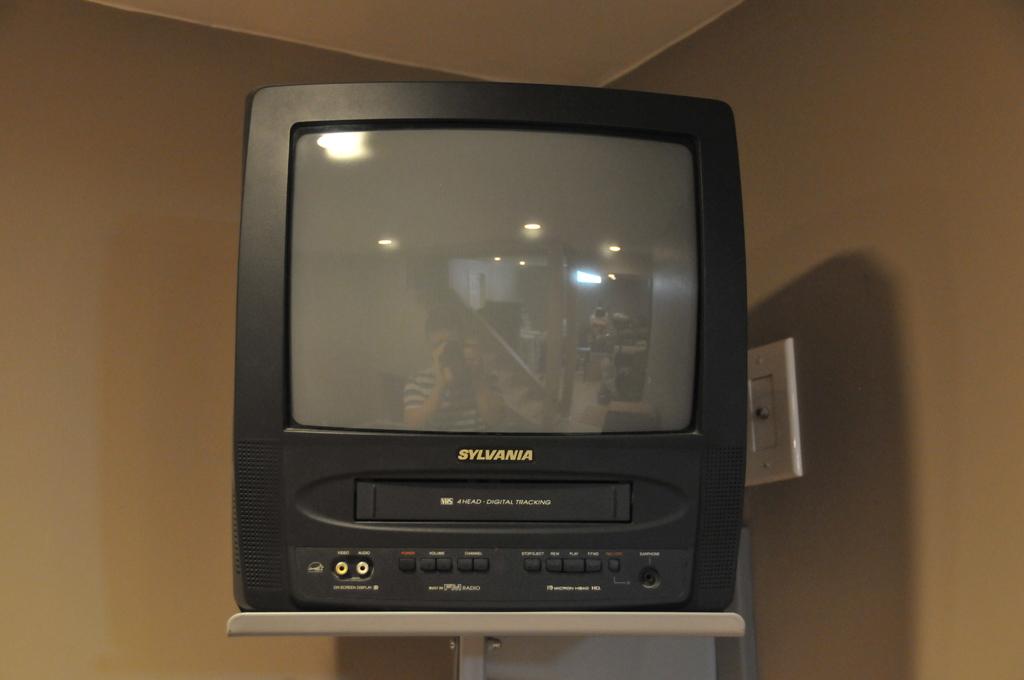Does this television have a built in dvd or vhs player?
Your answer should be compact. Vhs. What is the brand?
Provide a short and direct response. Sylvania. 